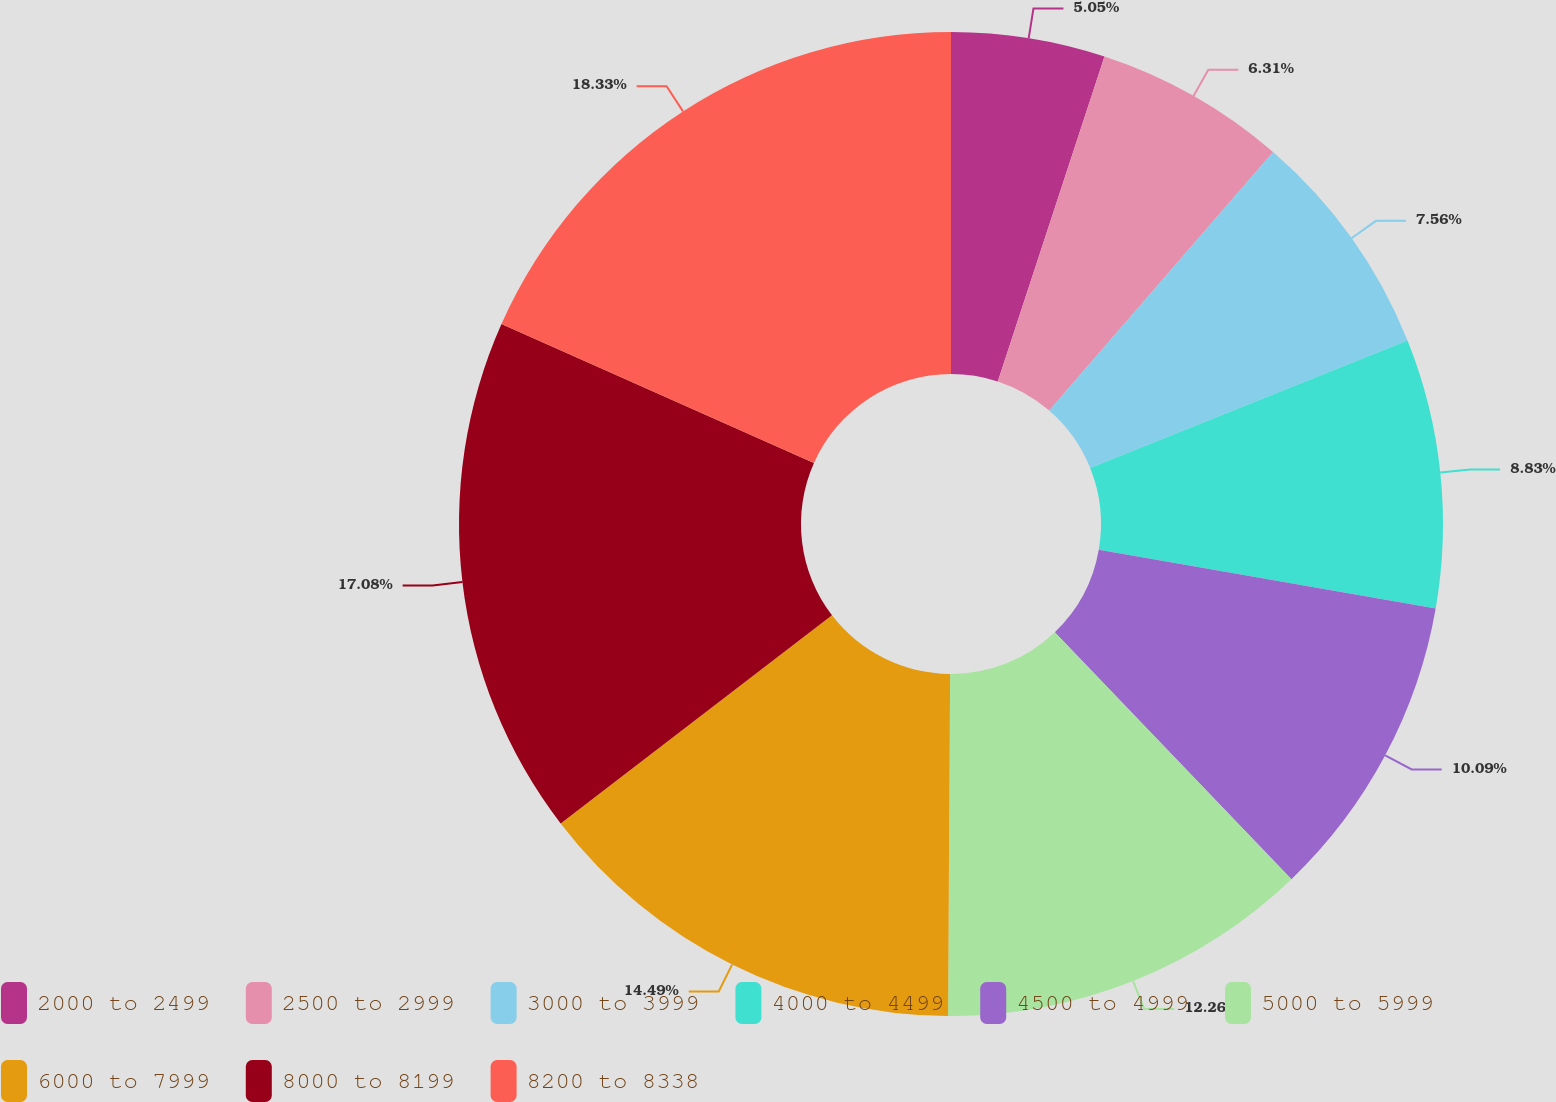Convert chart. <chart><loc_0><loc_0><loc_500><loc_500><pie_chart><fcel>2000 to 2499<fcel>2500 to 2999<fcel>3000 to 3999<fcel>4000 to 4499<fcel>4500 to 4999<fcel>5000 to 5999<fcel>6000 to 7999<fcel>8000 to 8199<fcel>8200 to 8338<nl><fcel>5.05%<fcel>6.31%<fcel>7.56%<fcel>8.83%<fcel>10.09%<fcel>12.26%<fcel>14.49%<fcel>17.08%<fcel>18.34%<nl></chart> 